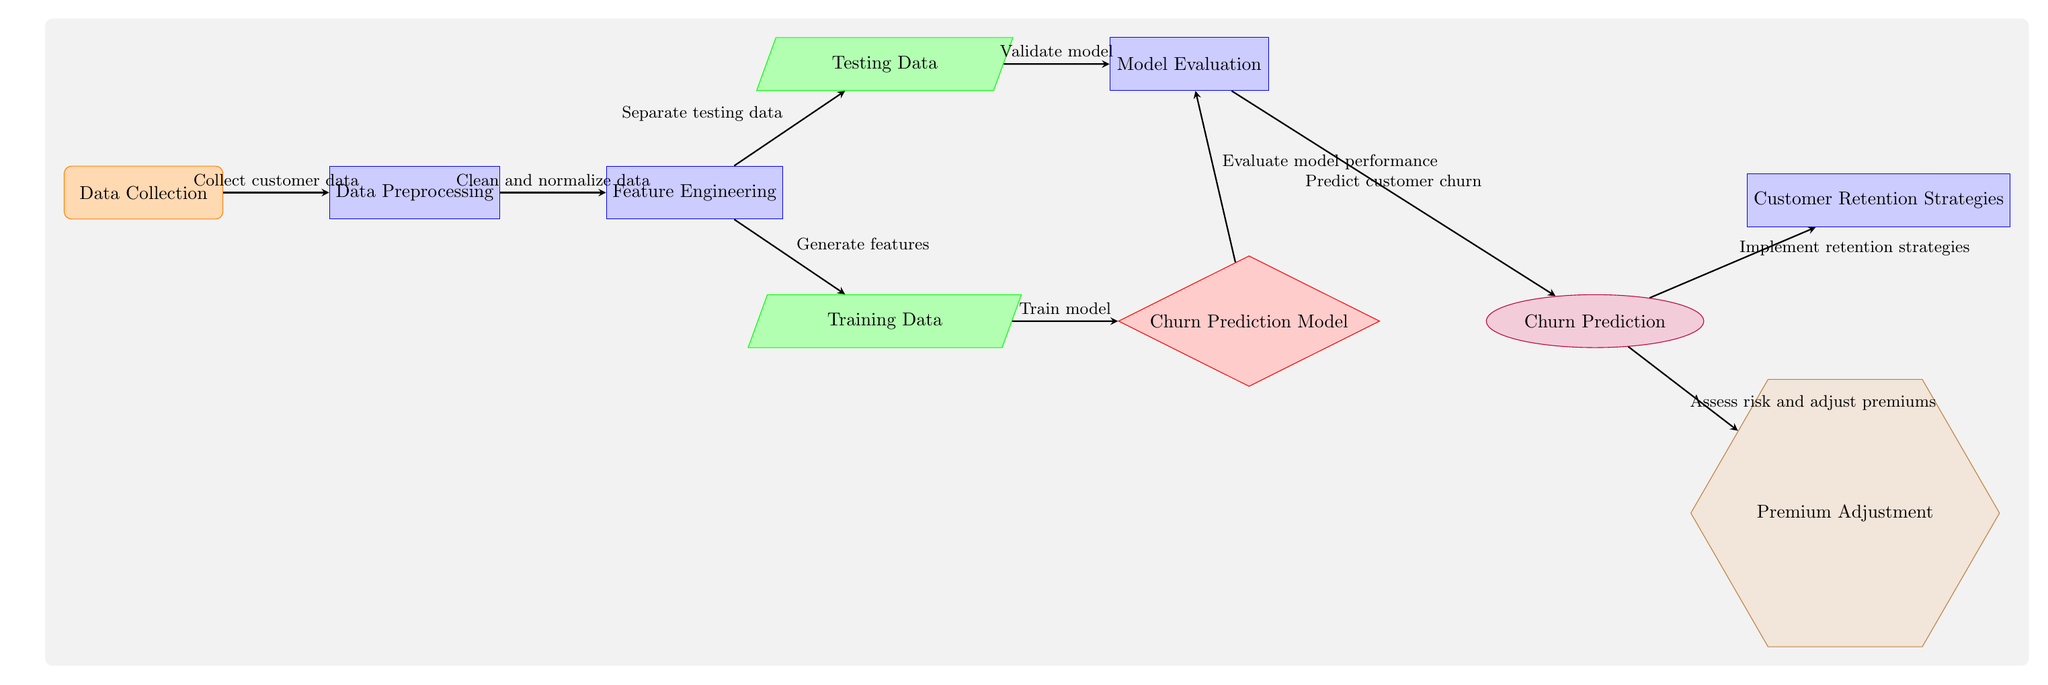What is the first step in this diagram? The diagram starts with "Data Collection," which is the initial process where customer data is gathered before any processing.
Answer: Data Collection How many main processes are shown in the diagram? By counting the rectangles, we find there are six main processes: Data Preprocessing, Feature Engineering, Model Evaluation, Churn Prediction, Customer Retention Strategies, and Premium Adjustment.
Answer: Six What shape represents the Churn Prediction Model? The Churn Prediction Model is represented as a diamond shape, which is typically used in diagrams to signify decision points or models.
Answer: Diamond What action follows after Model Evaluation? Following the Model Evaluation, the next action indicated is "Churn Prediction," which is a direct outcome of evaluating the model's performance.
Answer: Churn Prediction What is the relationship between "Churn Prediction" and "Premium Adjustment"? The relationship shows that after making predictions about customer churn, the next step is to "Assess risk and adjust premiums," indicating a direct flow from churn prediction to premium adjustment.
Answer: Direct flow How is the data split before training the model? The data is separated into two parts: "Training Data" and "Testing Data," which are both derived from the "Feature Engineering" step. This is an essential part of the model development process.
Answer: Split into Training and Testing Data What type of strategies are implemented after predicting customer churn? After the prediction of customer churn, "Customer Retention Strategies" are implemented aimed at retaining customers identified as at-risk of churning.
Answer: Customer Retention Strategies How does the diagram describe the processing of customer data? The diagram details a sequential processing of data that includes collecting, preprocessing, and feature engineering before training the churn prediction model. Each step builds on the previous one to ensure data integrity and model effectiveness.
Answer: Sequential processing What color is used for the output step of the diagram? The output step, labeled as "Churn Prediction," is filled with purple color, which distinguishes it from other processes in the diagram.
Answer: Purple 